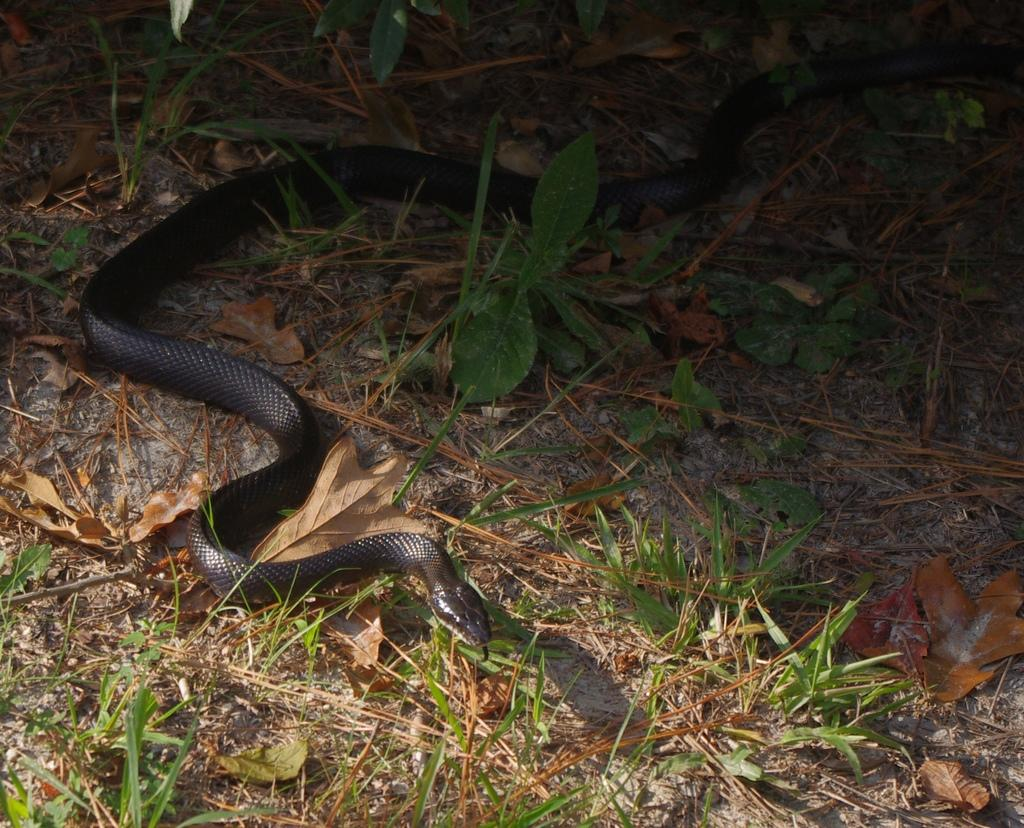What type of animal is in the image? There is a snake in the image. What color is the snake? The snake is black in color. What else can be seen in the image besides the snake? There are plants in the image. Can you tell me how much profit the snake made in the image? There is no information about profit in the image, as it features a snake and plants. 